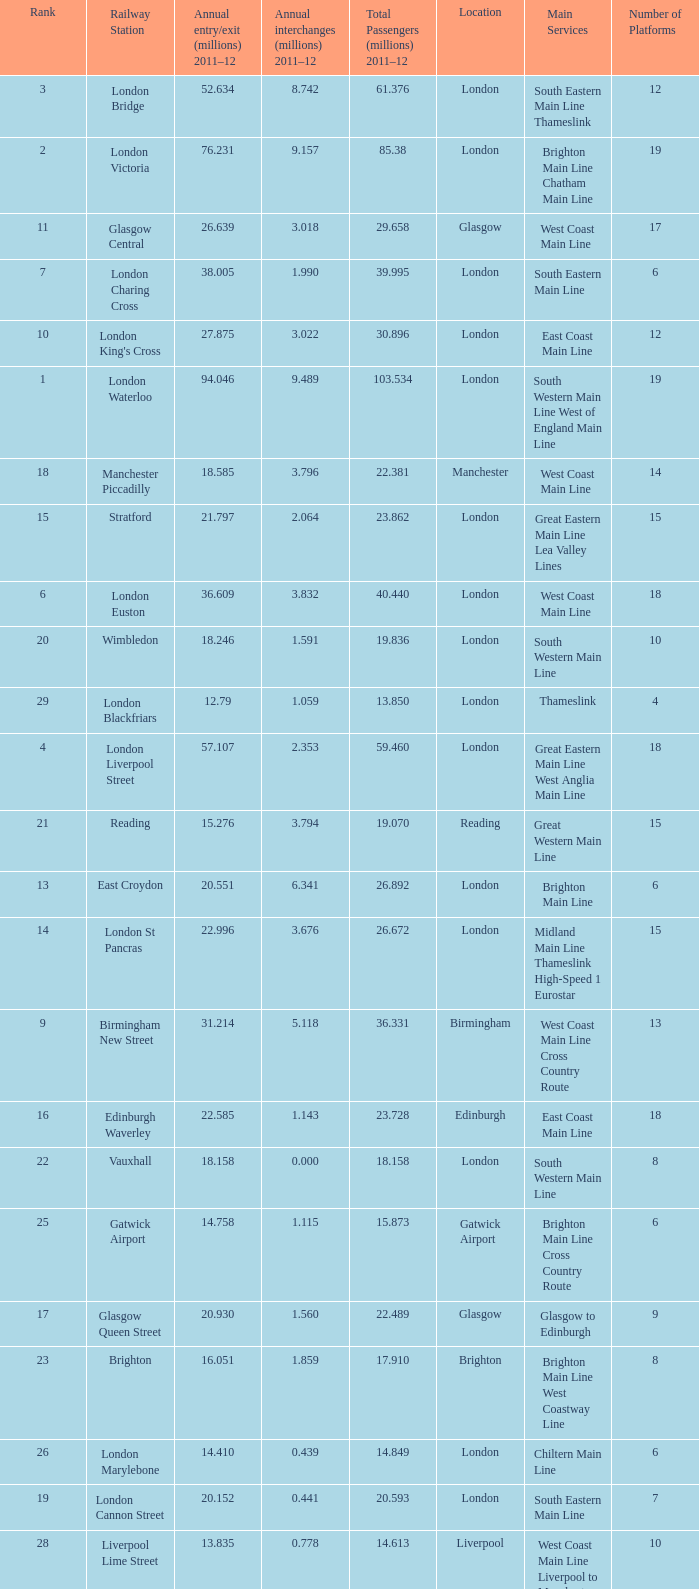What is the main service for the station with 14.849 million passengers 2011-12?  Chiltern Main Line. 